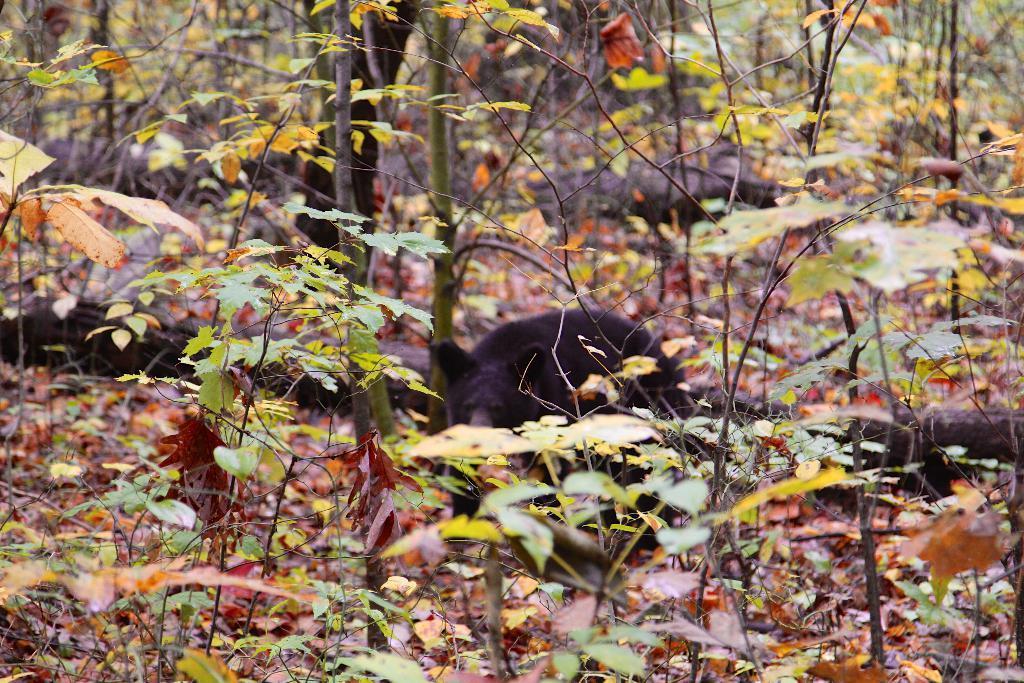Describe this image in one or two sentences. In this image I can see number of green and brown colour leaves. I can also see a black colour bear in background and I can see this image is little bit blurry from background. 